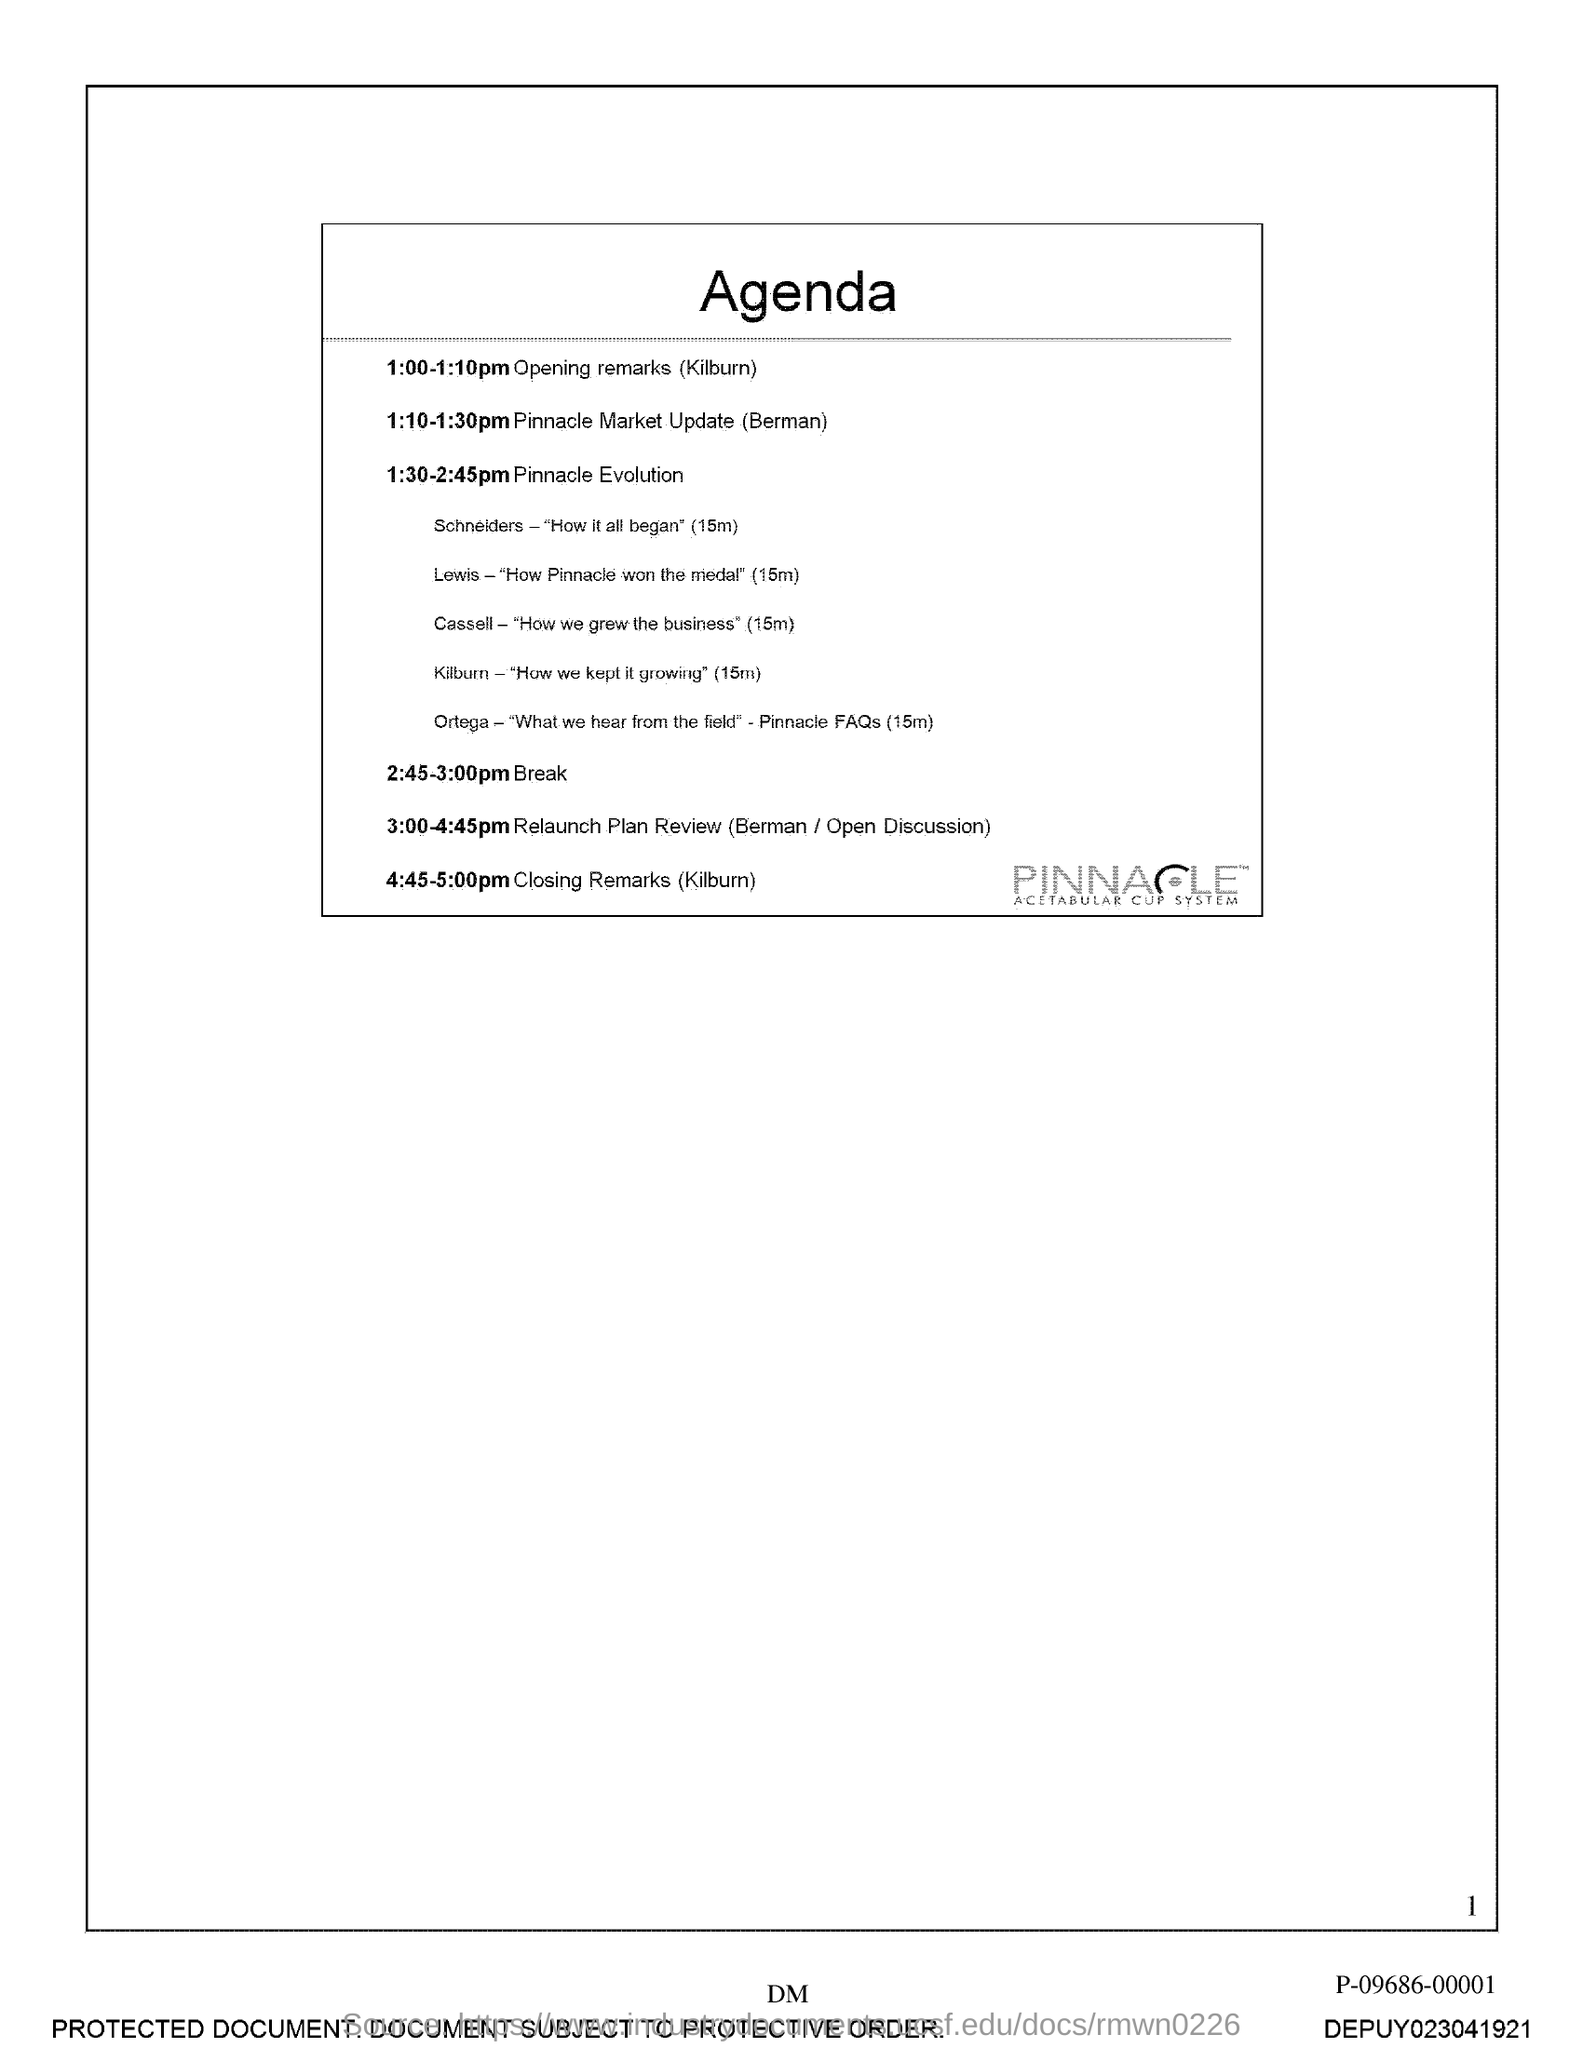What is the title of the document?
Offer a very short reply. Agenda. What is the Page Number?
Keep it short and to the point. 1. 